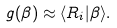<formula> <loc_0><loc_0><loc_500><loc_500>g ( \beta ) \approx \langle R _ { i } | \beta \rangle .</formula> 